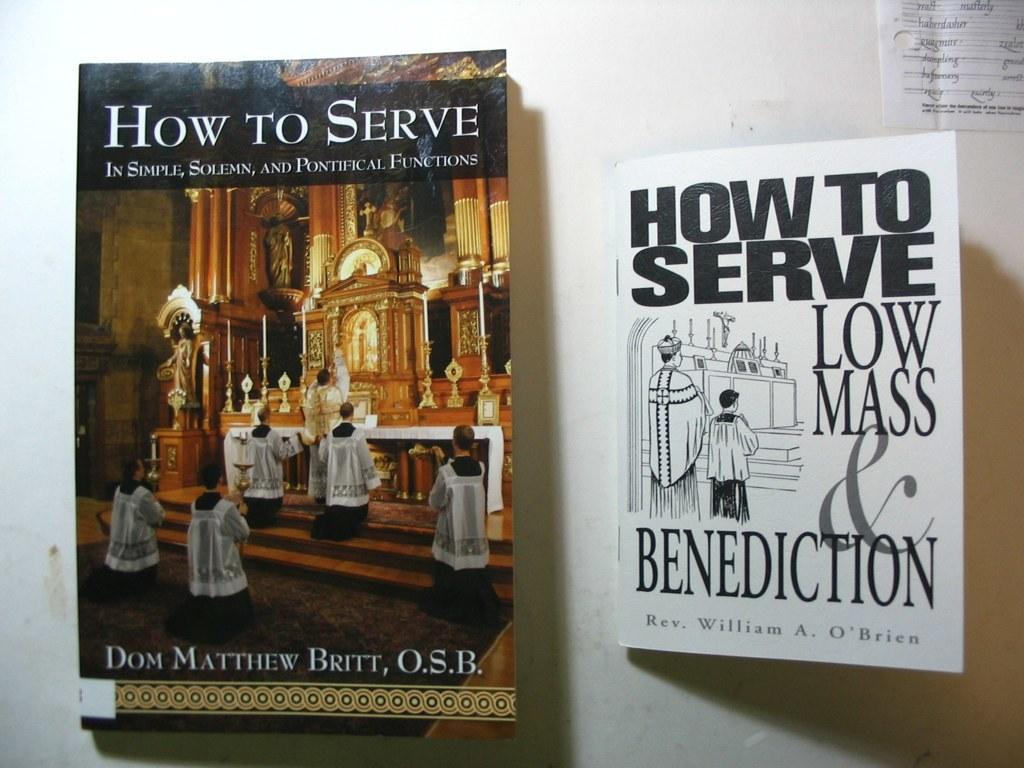Provide a one-sentence caption for the provided image. Two books on how to serve a Mass sit side by side. 